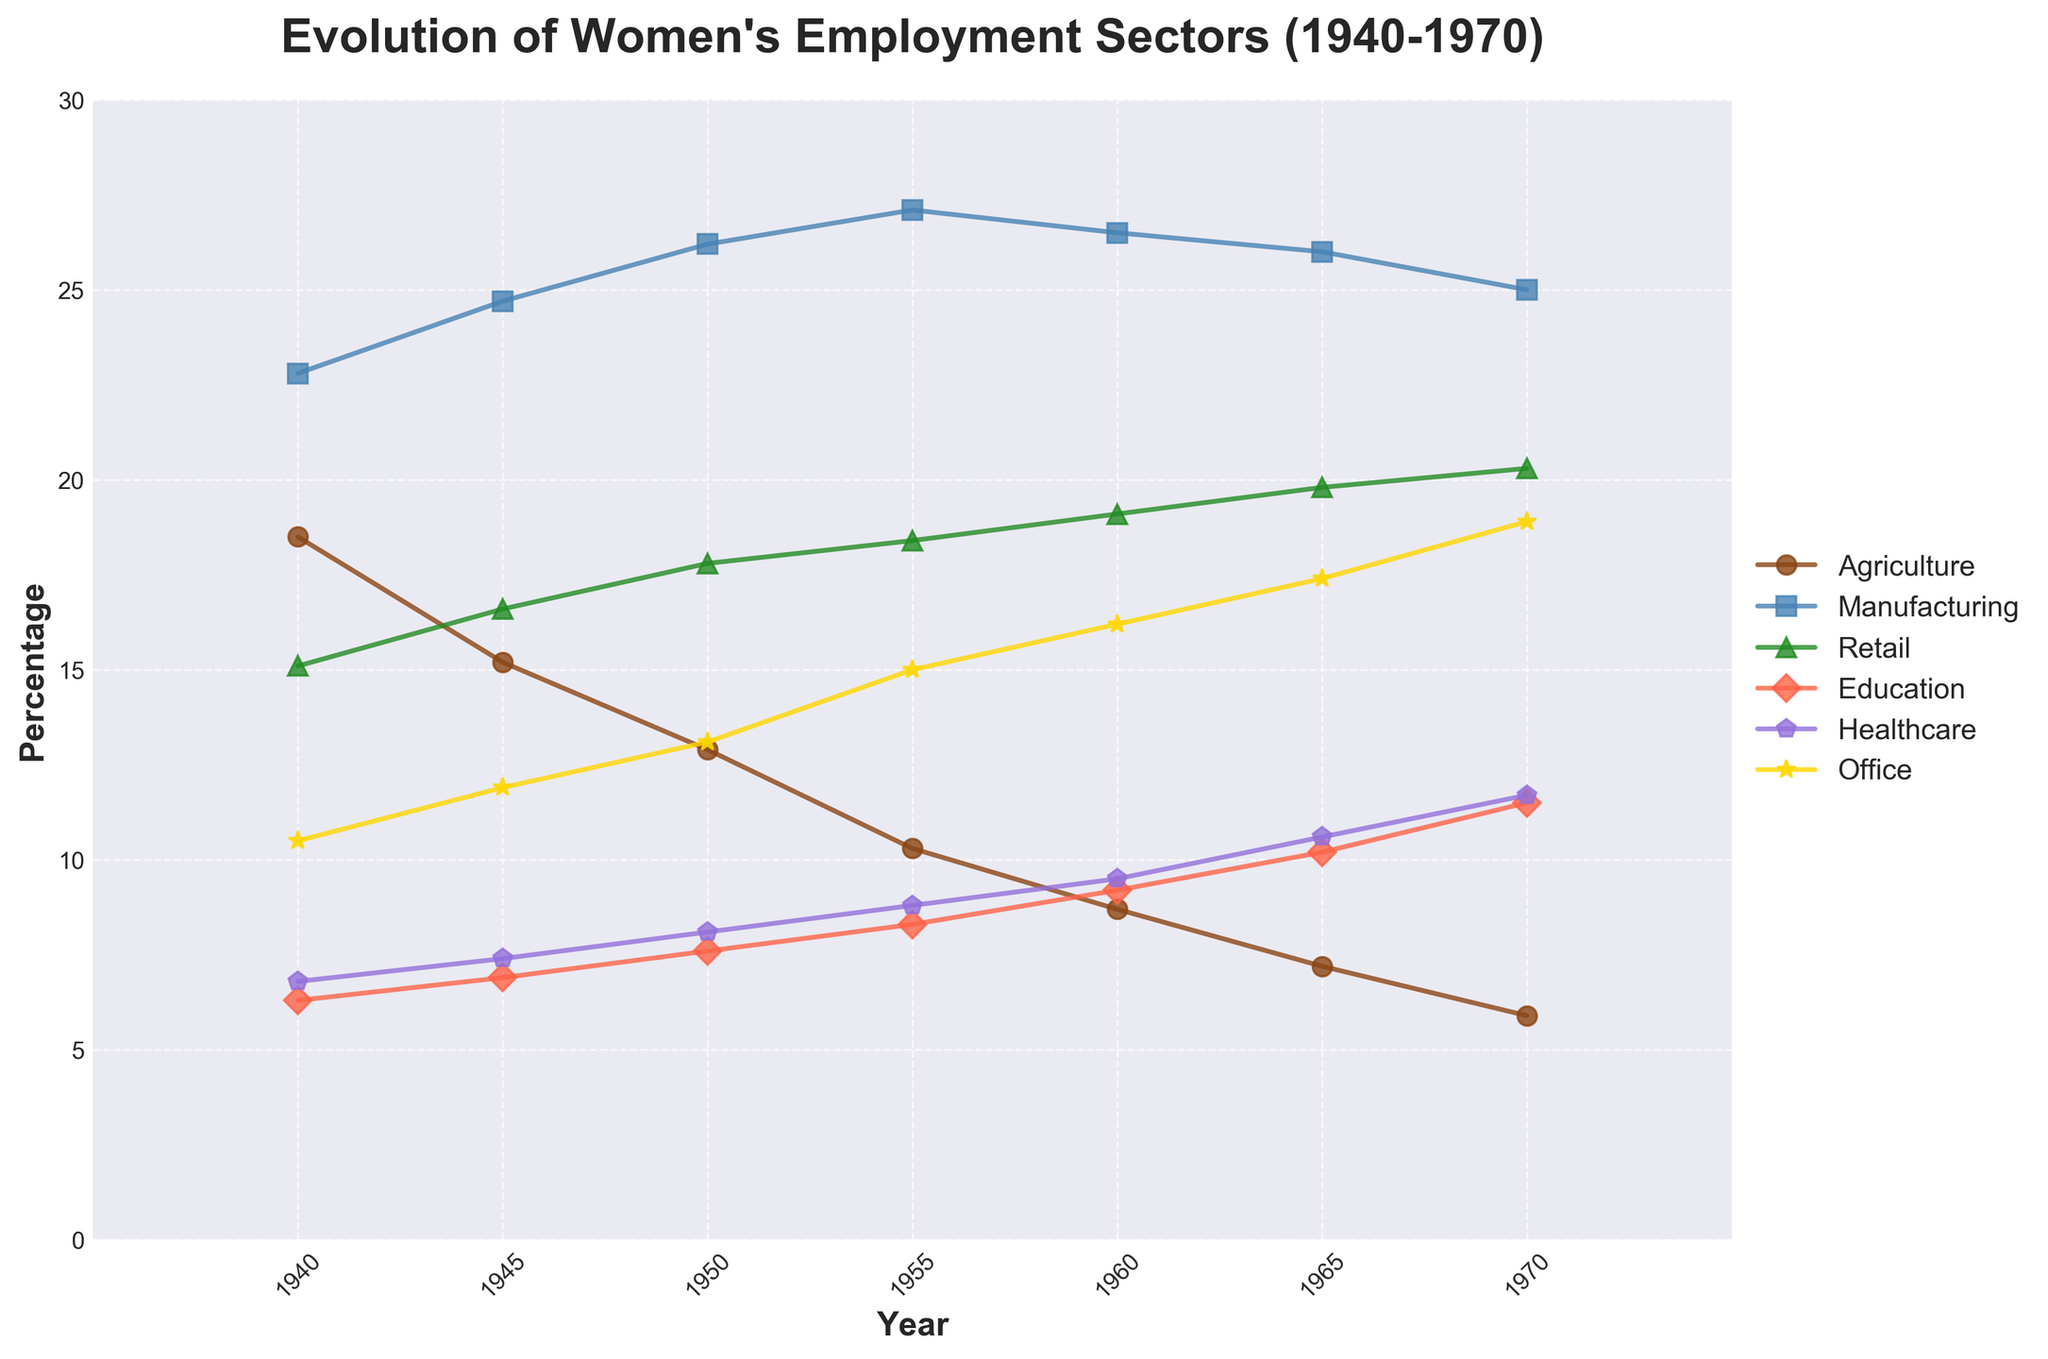What year has the highest percentage of women in manufacturing? Look at the line representing Manufacturing, identify the year where this line peaks. The peak is at 1955.
Answer: 1955 How much did the percentage of women in agriculture decrease from 1940 to 1970? Compare the percentage in 1940 (18.5%) with that in 1970 (5.9%). Subtract 5.9 from 18.5.
Answer: 12.6% Between 1955 and 1970, how did the employment share in healthcare change? Find the percentage in healthcare sector for the years 1955 and 1970. Calculate the difference between the two (11.7% - 8.8%).
Answer: 2.9% Which sector saw the most significant increase in women's employment from 1940 to 1970? Examine all sectors' percentage changes from 1940 to 1970. Calculate the increase for each and compare. The Office sector saw the largest increase (18.9% - 10.5%).
Answer: Office In 1960, which two sectors had almost equal percentages of women's employment? Compare the percentages for different sectors in 1960. Education (9.2%) and Healthcare (9.5%) were nearly equal.
Answer: Education and Healthcare What is the trend in women's employment in agriculture sector from 1940 to 1970? Follow the Agriculture line from 1940 to 1970. The trend is a continuous decline.
Answer: Decline Which sector saw the smallest change in women's employment from 1945 to 1970? Calculate the percentage change for each sector between 1945 and 1970. The Manufacturing sector changed the least (25 - 24.7).
Answer: Manufacturing Which sector had the highest percentage of women's employment in 1950? Identify the highest point among all sectors in the year 1950. Manufacturing is highest at 26.2%.
Answer: Manufacturing 